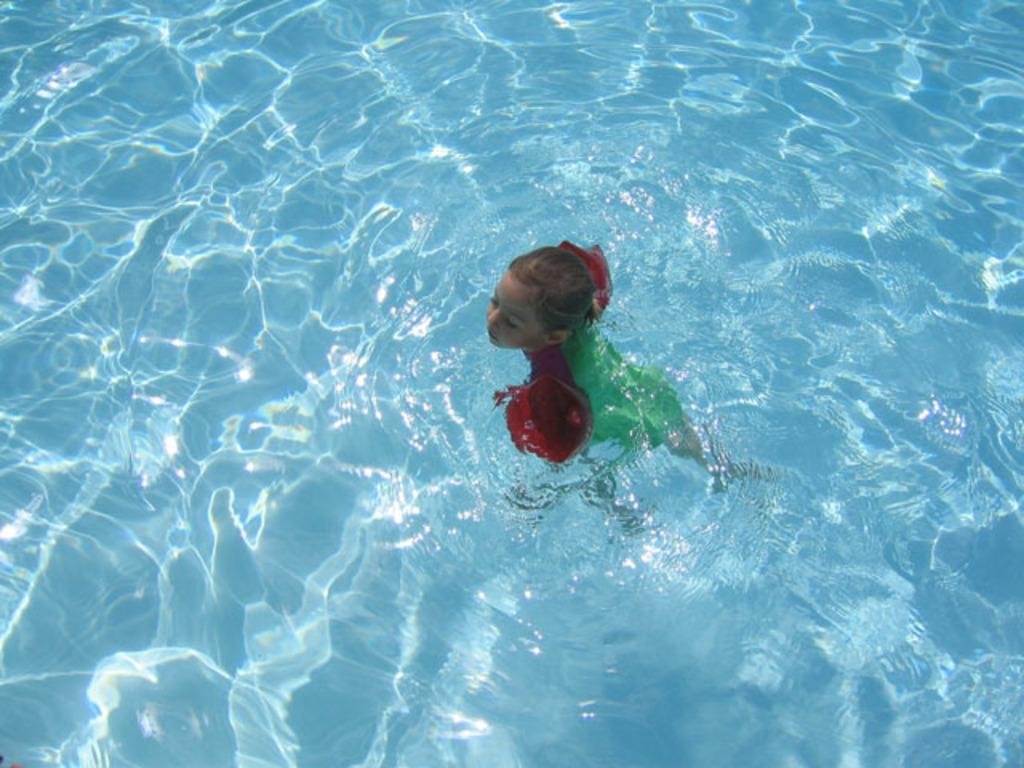Who is the main subject in the image? There is a girl in the image. What is the girl doing in the image? The girl is swimming in the image. Where is the girl swimming? The girl is swimming in a pool. How many cows are present in the image? There are no cows present in the image; it features a girl swimming in a pool. What type of cloth is being used by the girl to swim in the image? The girl is not using any cloth specifically for swimming in the image; she is likely wearing a swimsuit. 